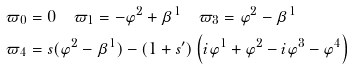Convert formula to latex. <formula><loc_0><loc_0><loc_500><loc_500>\varpi _ { 0 } & = 0 \quad \varpi _ { 1 } = - \varphi ^ { 2 } + \beta ^ { 1 } \quad \varpi _ { 3 } = \varphi ^ { 2 } - \beta ^ { 1 } \\ \varpi _ { 4 } & = s ( \varphi ^ { 2 } - \beta ^ { 1 } ) - ( 1 + s ^ { \prime } ) \left ( i \varphi ^ { 1 } + \varphi ^ { 2 } - i \varphi ^ { 3 } - \varphi ^ { 4 } \right )</formula> 